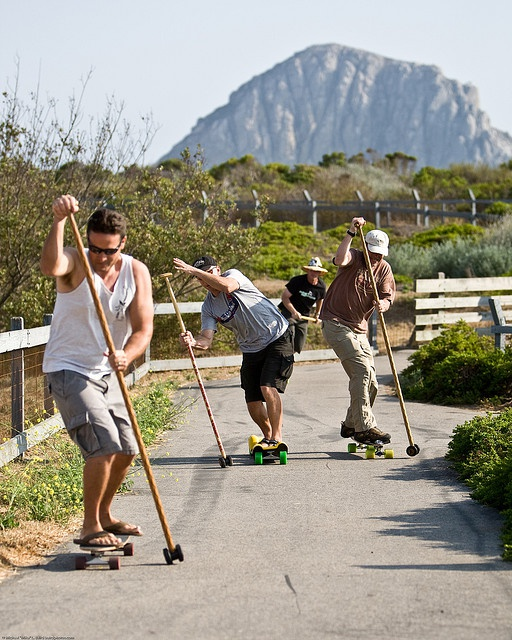Describe the objects in this image and their specific colors. I can see people in lightgray, darkgray, maroon, and gray tones, people in lightgray, black, gray, and olive tones, people in lightgray, black, maroon, and ivory tones, people in lightgray, black, gray, and maroon tones, and skateboard in lightgray, black, gray, darkgray, and tan tones in this image. 